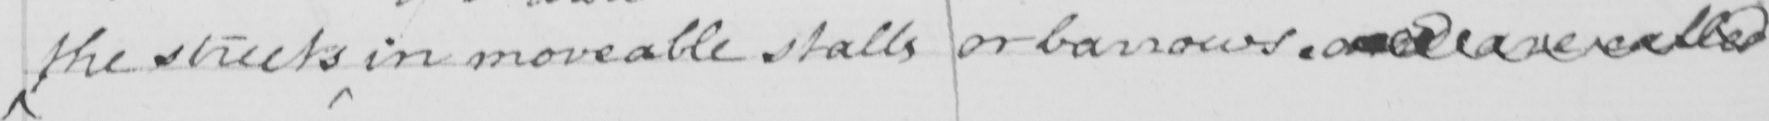Can you tell me what this handwritten text says? the streets in moveable stalls or barrows and are called 